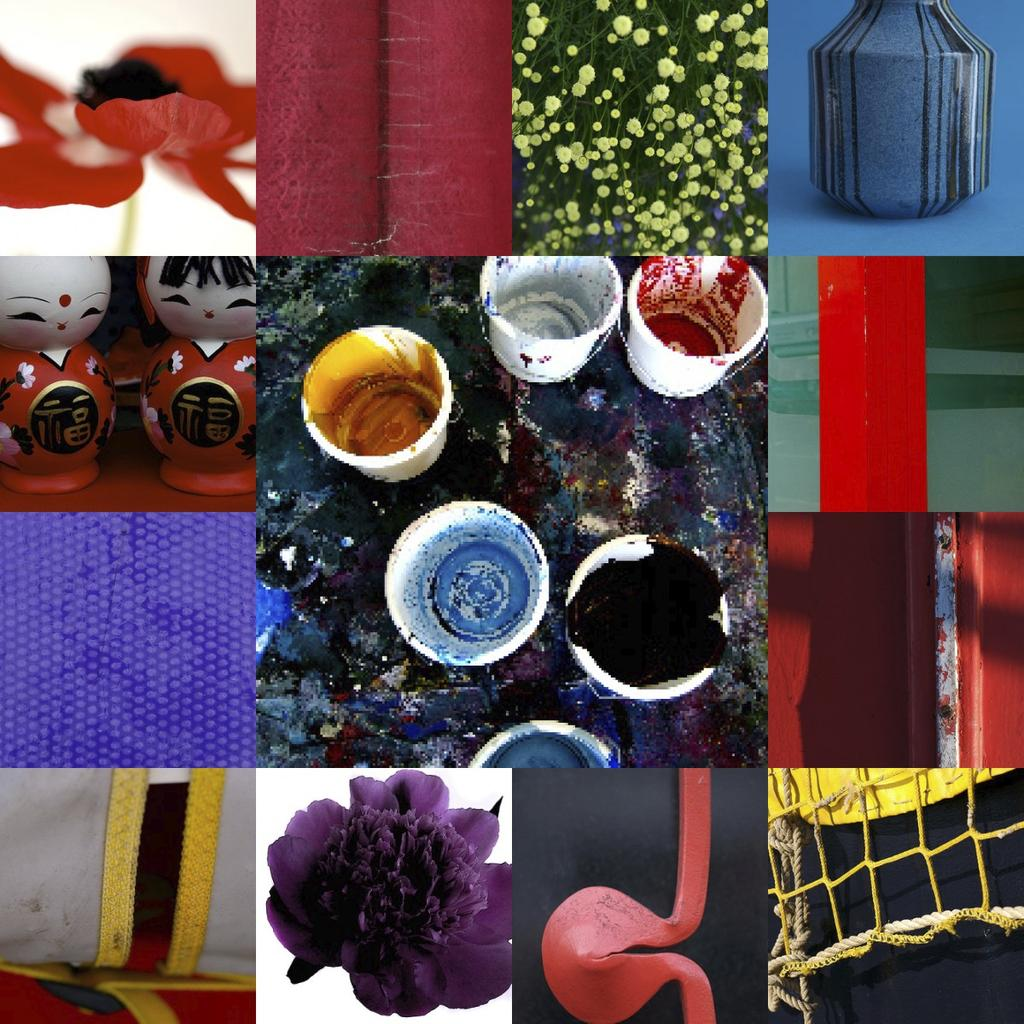What type of artwork is present in the image? The image contains paintings. What other objects can be seen in the image besides paintings? There are flowers, dolls, a net, walls, and a flower vase in the image. How are the flowers arranged in the image? The flowers are arranged in a vase in the image. What might be used to catch or hold objects in the image? The net in the image might be used to catch or hold objects. What type of soup is being served in the image? There is no soup present in the image. Can you see a plane in the image? There is no plane present in the image. 